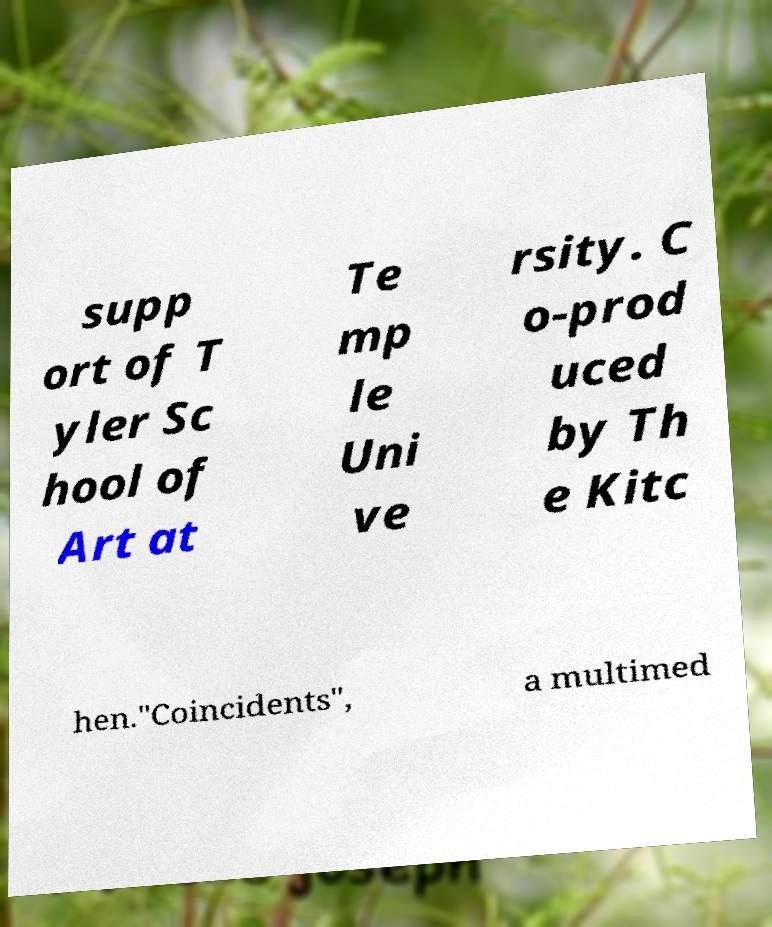Can you read and provide the text displayed in the image?This photo seems to have some interesting text. Can you extract and type it out for me? supp ort of T yler Sc hool of Art at Te mp le Uni ve rsity. C o-prod uced by Th e Kitc hen."Coincidents", a multimed 